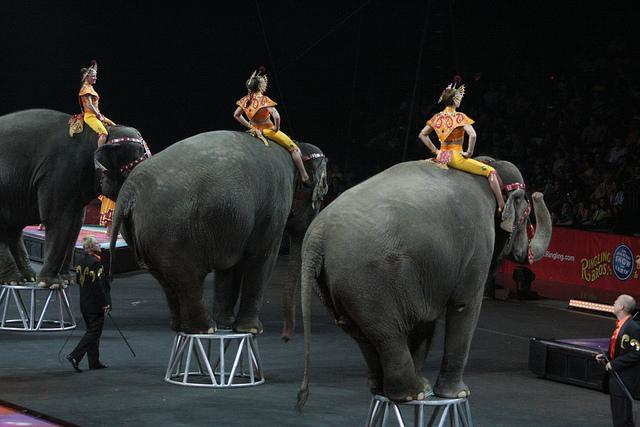What will the man do to the elephants with the sticks he holds? tap them 